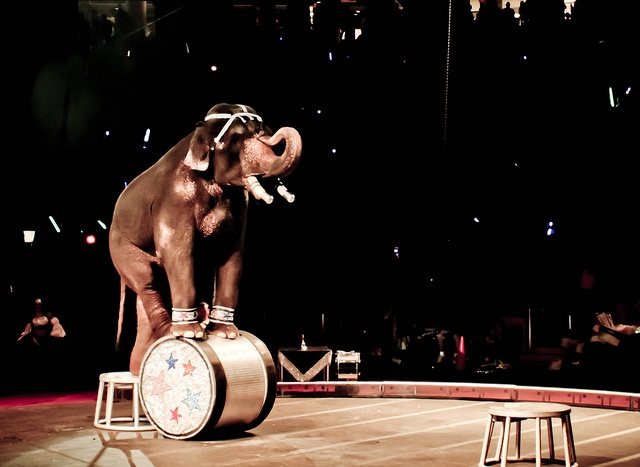Describe the objects in this image and their specific colors. I can see elephant in black, brown, and maroon tones, people in black, brown, maroon, and tan tones, and people in black, maroon, and brown tones in this image. 